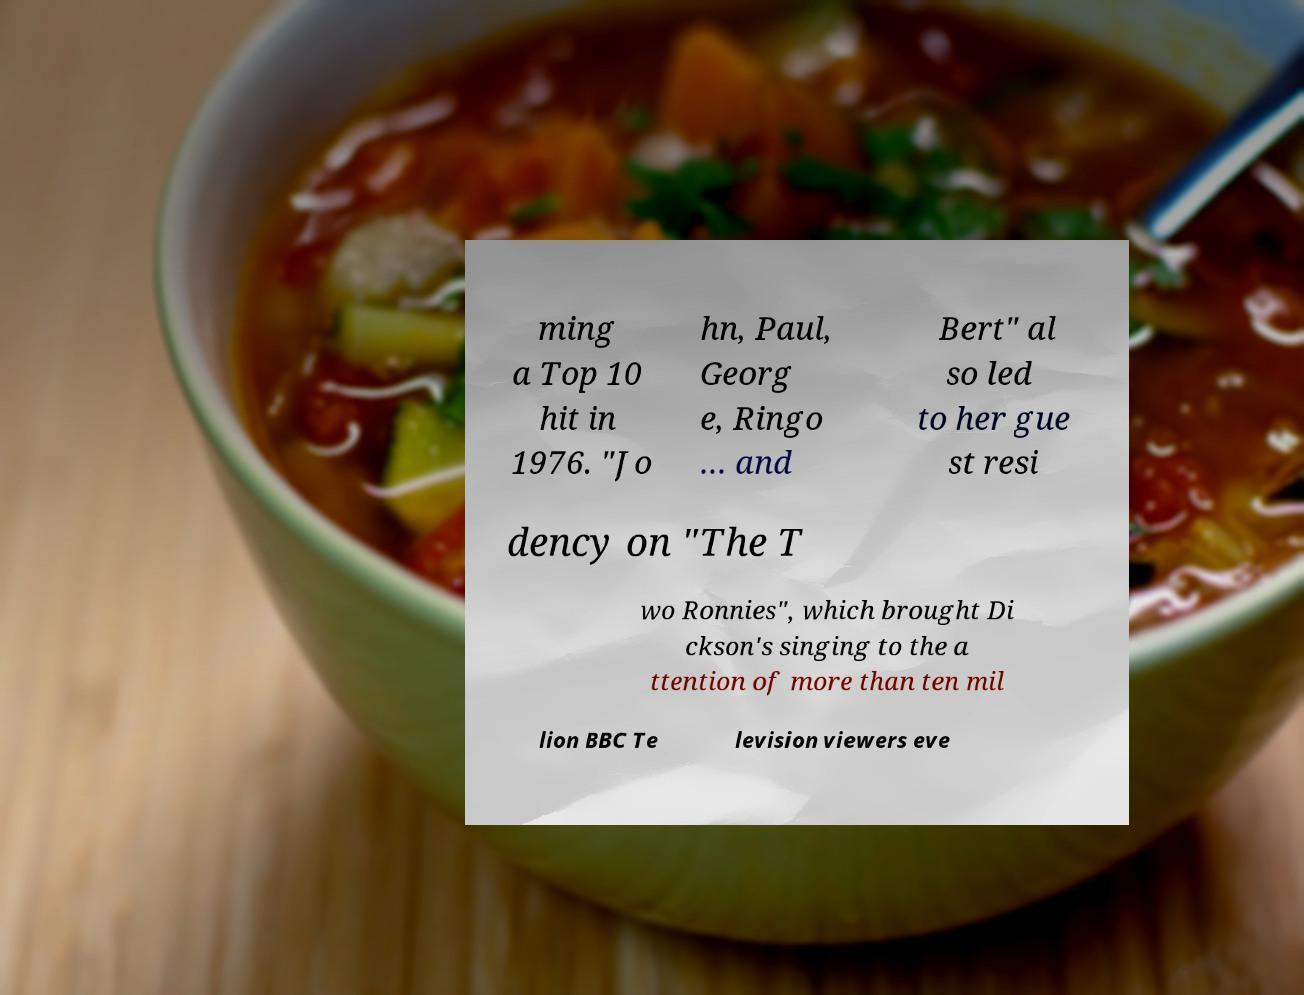Please identify and transcribe the text found in this image. ming a Top 10 hit in 1976. "Jo hn, Paul, Georg e, Ringo … and Bert" al so led to her gue st resi dency on "The T wo Ronnies", which brought Di ckson's singing to the a ttention of more than ten mil lion BBC Te levision viewers eve 